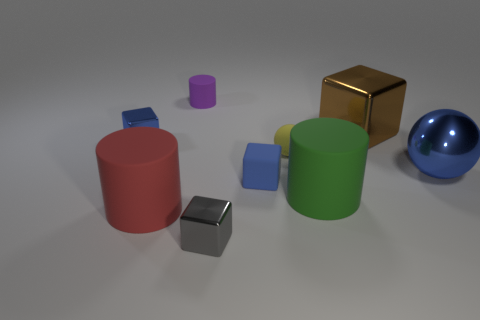There is a large shiny sphere; does it have the same color as the rubber cylinder behind the large brown thing?
Give a very brief answer. No. What size is the cube that is both in front of the blue metal ball and behind the red rubber thing?
Provide a succinct answer. Small. Are there any small rubber things in front of the big brown block?
Your answer should be compact. Yes. There is a blue shiny object left of the tiny gray metallic object; is there a small gray cube in front of it?
Ensure brevity in your answer.  Yes. Is the number of big shiny cubes in front of the big brown thing the same as the number of small blue metal cubes that are behind the tiny yellow ball?
Provide a succinct answer. No. What color is the block that is the same material as the yellow sphere?
Provide a short and direct response. Blue. Are there any cylinders made of the same material as the big blue thing?
Offer a very short reply. No. What number of objects are big green things or large brown rubber objects?
Your answer should be very brief. 1. Are the purple cylinder and the block to the right of the yellow rubber object made of the same material?
Give a very brief answer. No. There is a metal sphere to the right of the red matte thing; how big is it?
Give a very brief answer. Large. 